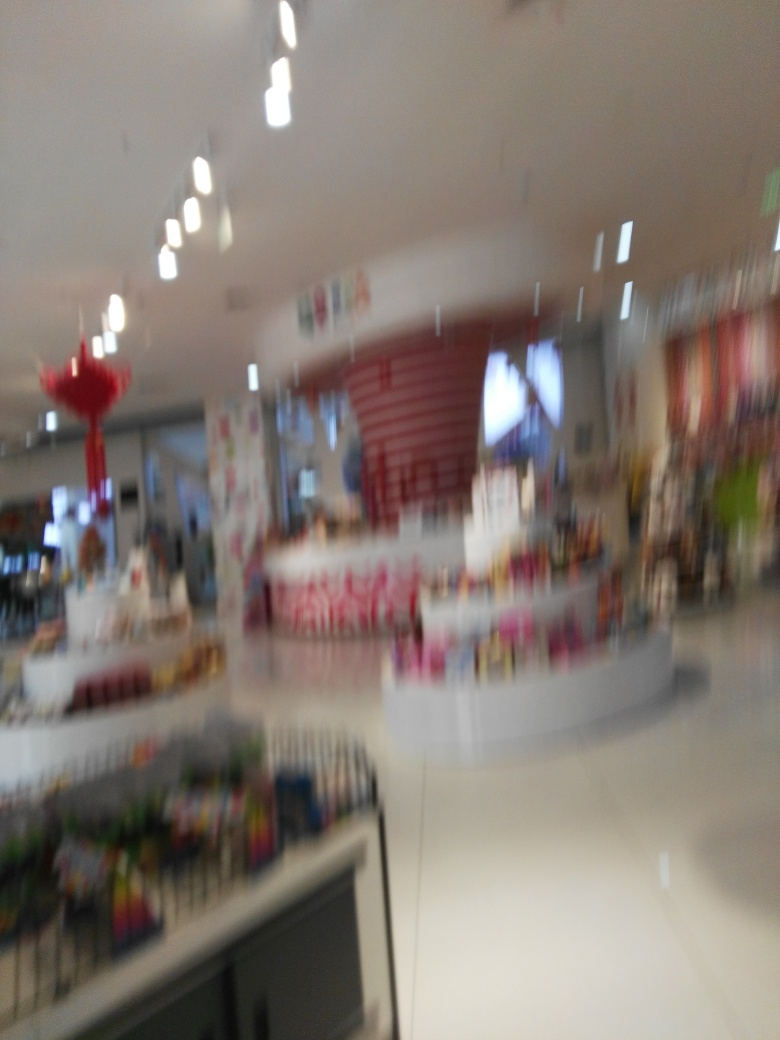What might this place be used for? Although the image is blurred, the general layout suggests a commercial retail space, possibly a store or a boutique, where customers can browse and shop for items. 